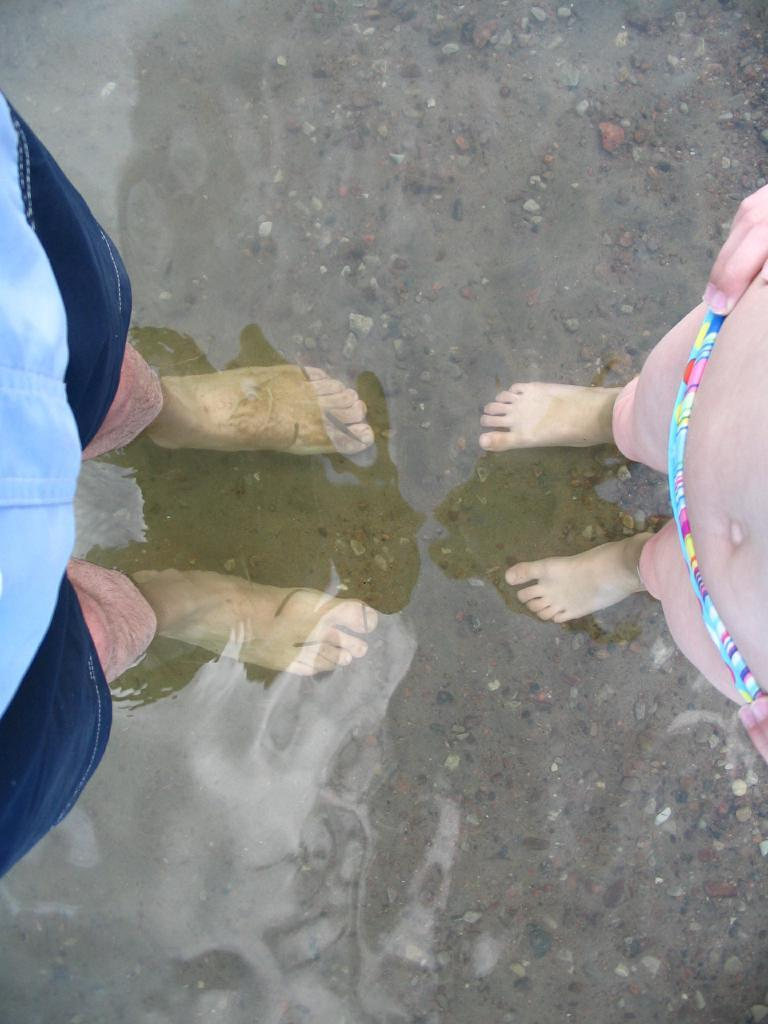How many people are in the water in the image? There are two persons standing in the water in the image. What distinguishes the costumes of the two persons? The two persons are in different costumes. What type of environment is depicted in the image? There is water and sand visible in the background, suggesting a beach or similar location. What type of secretary can be seen working on the playground in the image? There is no secretary or playground present in the image; it features two persons standing in the water in different costumes. 